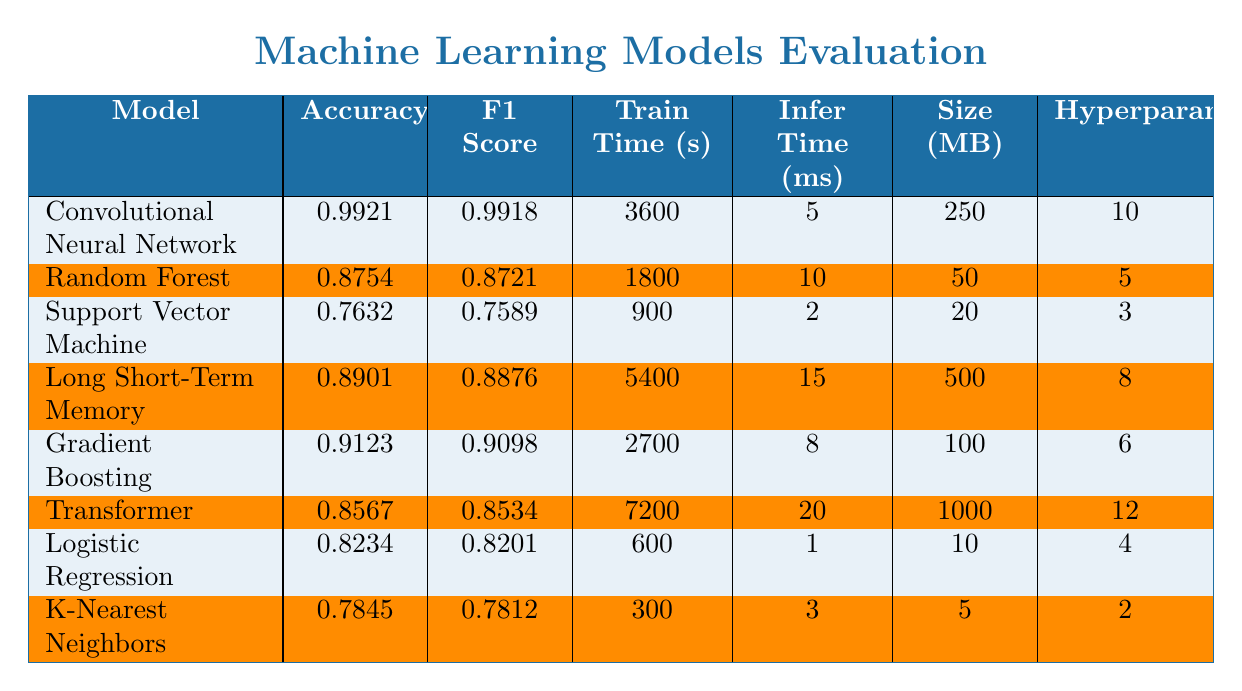What is the accuracy score of the Convolutional Neural Network model? The Convolutional Neural Network model's accuracy score is listed directly in its row under the 'Accuracy' column. The value is 0.9921.
Answer: 0.9921 Which model has the highest F1 score? The F1 score is highest for the Convolutional Neural Network, which is 0.9918, as indicated in its corresponding row under the 'F1 Score' column.
Answer: Convolutional Neural Network What is the training time in seconds for the Random Forest model? The training time for the Random Forest model is provided in its respective row under the 'Train Time (s)' column. The value indicated is 1800 seconds.
Answer: 1800 Is the model size of the Support Vector Machine greater than 30 MB? The size for the Support Vector Machine is 20 MB according to the 'Size (MB)' column, which is less than 30 MB. Thus, the answer is no.
Answer: No What is the average inference time for all models? To find the average inference time, sum the inference times (5 + 10 + 2 + 15 + 8 + 20 + 1 + 3 = 64) and divide by the number of models (8). Thus, the average is 64 / 8 = 8.
Answer: 8 How many hyperparameters are tuned for the Gradient Boosting model? The number of hyperparameters tuned for the Gradient Boosting model can be found in its corresponding row under the 'Hyperparams' column. The value is 6.
Answer: 6 Which model has the longest training time, and what is that time? By comparing the training times of all models listed in the 'Train Time (s)' column, the Long Short-Term Memory model has the longest training time at 5400 seconds.
Answer: Long Short-Term Memory, 5400 seconds What is the difference in accuracy between the Logistic Regression and K-Nearest Neighbors models? The accuracy for Logistic Regression is 0.8234 and for K-Nearest Neighbors is 0.7845. The difference is calculated as 0.8234 - 0.7845 = 0.0389.
Answer: 0.0389 Which model has the largest size, and how does it compare to the second largest? The largest model size is for the Transformer at 1000 MB, while the second largest is the Long Short-Term Memory at 500 MB. The difference in size is 1000 - 500 = 500 MB.
Answer: Transformer, 500 MB larger Is the training time of the Long Short-Term Memory model more than five times that of the K-Nearest Neighbors? The training time for Long Short-Term Memory is 5400 seconds, and for K-Nearest Neighbors it is 300 seconds. To check, calculate 5 times the K-Nearest Neighbors' training time (5 * 300 = 1500). Since 5400 > 1500, the answer is yes.
Answer: Yes 